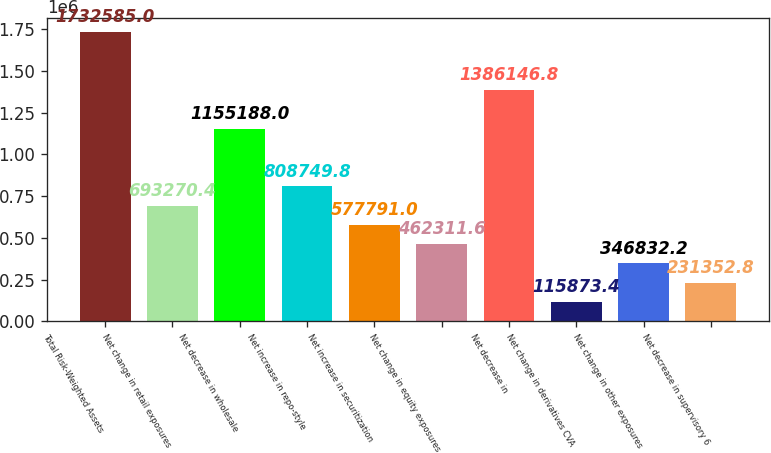<chart> <loc_0><loc_0><loc_500><loc_500><bar_chart><fcel>Total Risk-Weighted Assets<fcel>Net change in retail exposures<fcel>Net decrease in wholesale<fcel>Net increase in repo-style<fcel>Net increase in securitization<fcel>Net change in equity exposures<fcel>Net decrease in<fcel>Net change in derivatives CVA<fcel>Net change in other exposures<fcel>Net decrease in supervisory 6<nl><fcel>1.73258e+06<fcel>693270<fcel>1.15519e+06<fcel>808750<fcel>577791<fcel>462312<fcel>1.38615e+06<fcel>115873<fcel>346832<fcel>231353<nl></chart> 